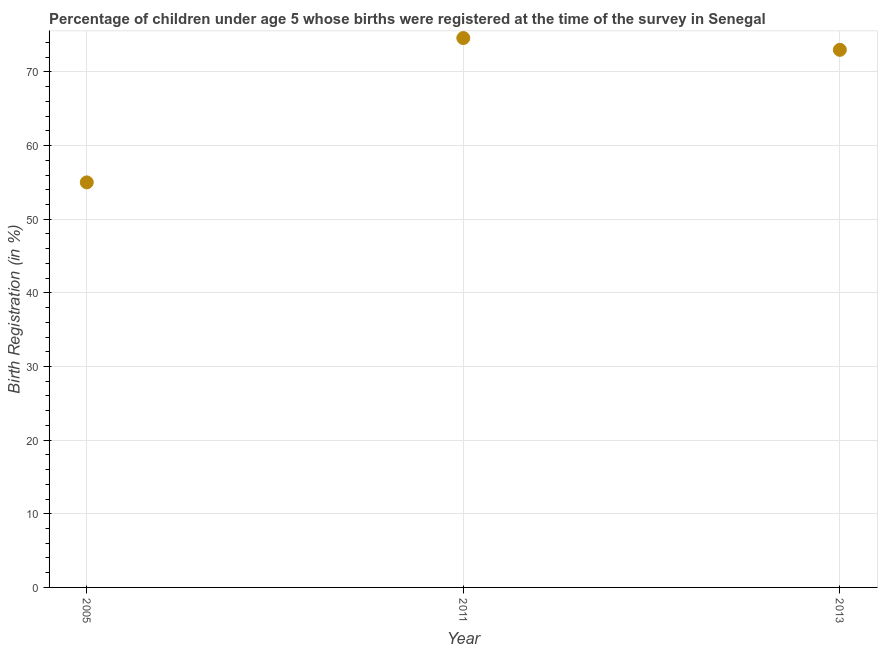What is the birth registration in 2005?
Offer a terse response. 55. Across all years, what is the maximum birth registration?
Make the answer very short. 74.6. What is the sum of the birth registration?
Your response must be concise. 202.6. What is the difference between the birth registration in 2005 and 2011?
Give a very brief answer. -19.6. What is the average birth registration per year?
Give a very brief answer. 67.53. What is the median birth registration?
Offer a terse response. 73. What is the ratio of the birth registration in 2011 to that in 2013?
Keep it short and to the point. 1.02. Is the difference between the birth registration in 2005 and 2013 greater than the difference between any two years?
Ensure brevity in your answer.  No. What is the difference between the highest and the second highest birth registration?
Give a very brief answer. 1.6. Is the sum of the birth registration in 2005 and 2013 greater than the maximum birth registration across all years?
Your answer should be very brief. Yes. What is the difference between the highest and the lowest birth registration?
Offer a very short reply. 19.6. In how many years, is the birth registration greater than the average birth registration taken over all years?
Ensure brevity in your answer.  2. Does the birth registration monotonically increase over the years?
Your answer should be very brief. No. How many dotlines are there?
Provide a short and direct response. 1. Does the graph contain any zero values?
Provide a short and direct response. No. What is the title of the graph?
Your answer should be very brief. Percentage of children under age 5 whose births were registered at the time of the survey in Senegal. What is the label or title of the Y-axis?
Your answer should be very brief. Birth Registration (in %). What is the Birth Registration (in %) in 2005?
Ensure brevity in your answer.  55. What is the Birth Registration (in %) in 2011?
Your response must be concise. 74.6. What is the Birth Registration (in %) in 2013?
Give a very brief answer. 73. What is the difference between the Birth Registration (in %) in 2005 and 2011?
Give a very brief answer. -19.6. What is the difference between the Birth Registration (in %) in 2011 and 2013?
Your response must be concise. 1.6. What is the ratio of the Birth Registration (in %) in 2005 to that in 2011?
Provide a succinct answer. 0.74. What is the ratio of the Birth Registration (in %) in 2005 to that in 2013?
Provide a succinct answer. 0.75. 